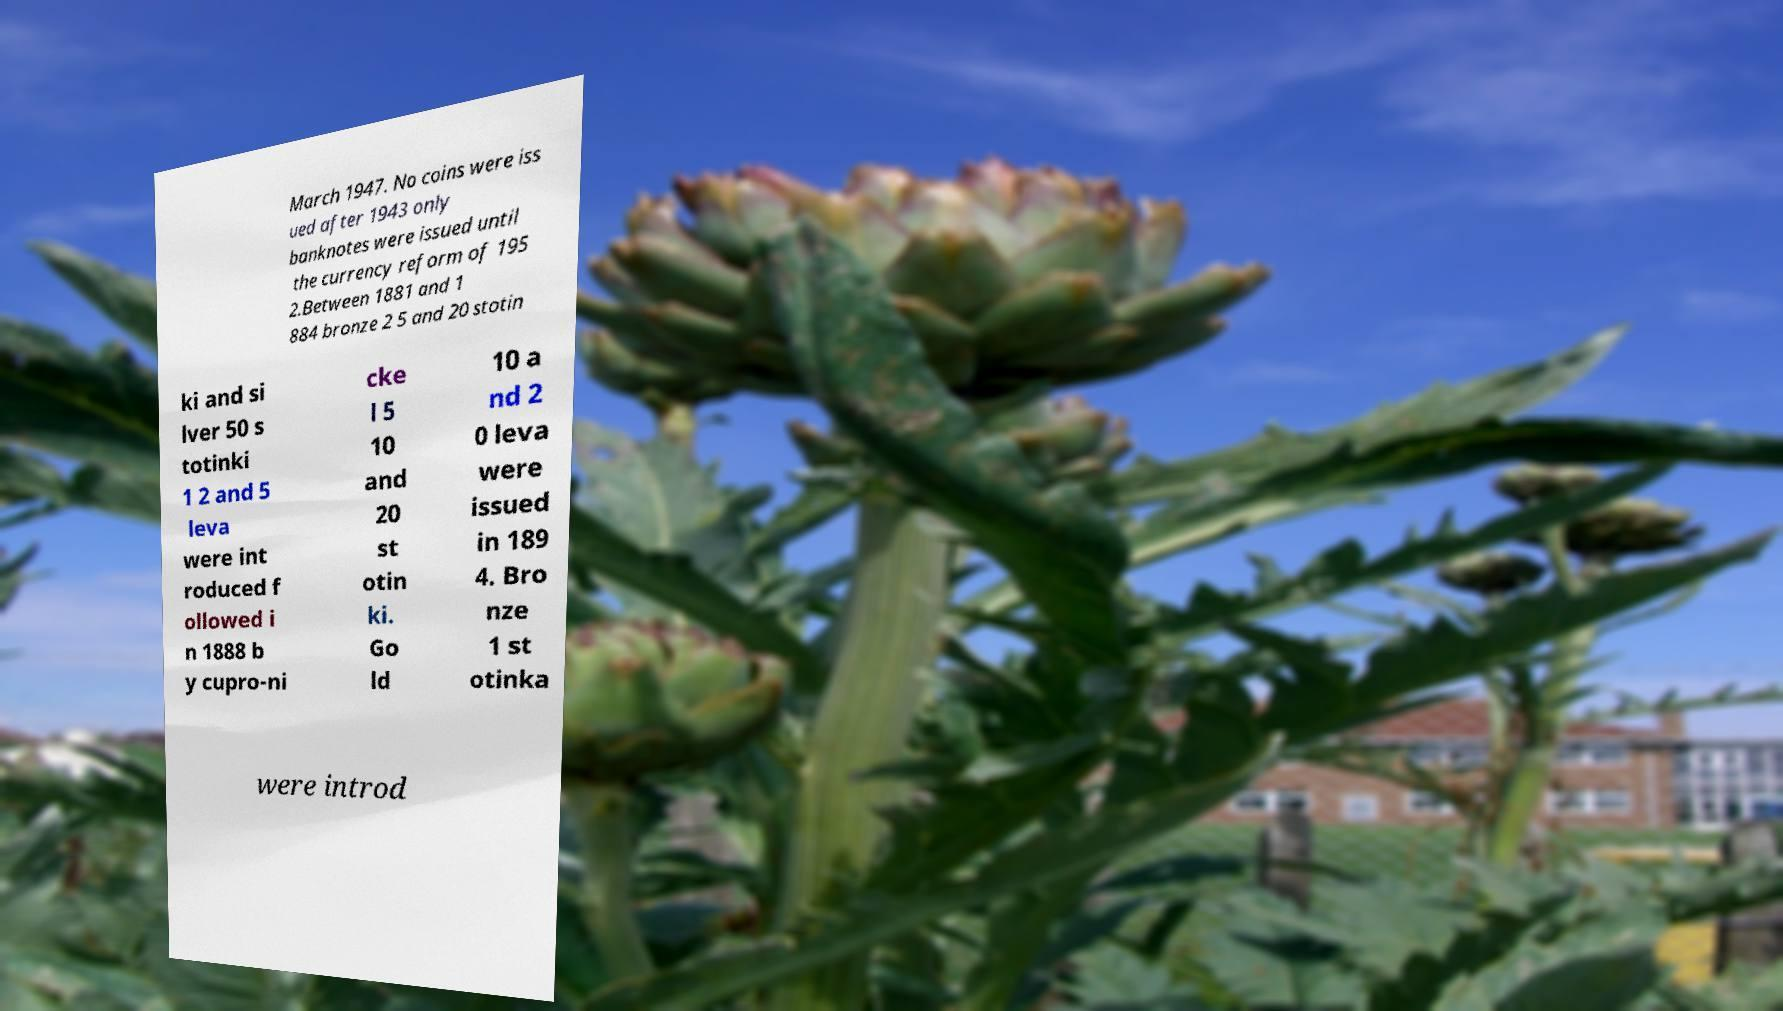Can you read and provide the text displayed in the image?This photo seems to have some interesting text. Can you extract and type it out for me? March 1947. No coins were iss ued after 1943 only banknotes were issued until the currency reform of 195 2.Between 1881 and 1 884 bronze 2 5 and 20 stotin ki and si lver 50 s totinki 1 2 and 5 leva were int roduced f ollowed i n 1888 b y cupro-ni cke l 5 10 and 20 st otin ki. Go ld 10 a nd 2 0 leva were issued in 189 4. Bro nze 1 st otinka were introd 